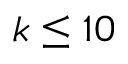Convert formula to latex. <formula><loc_0><loc_0><loc_500><loc_500>k \leq 1 0</formula> 